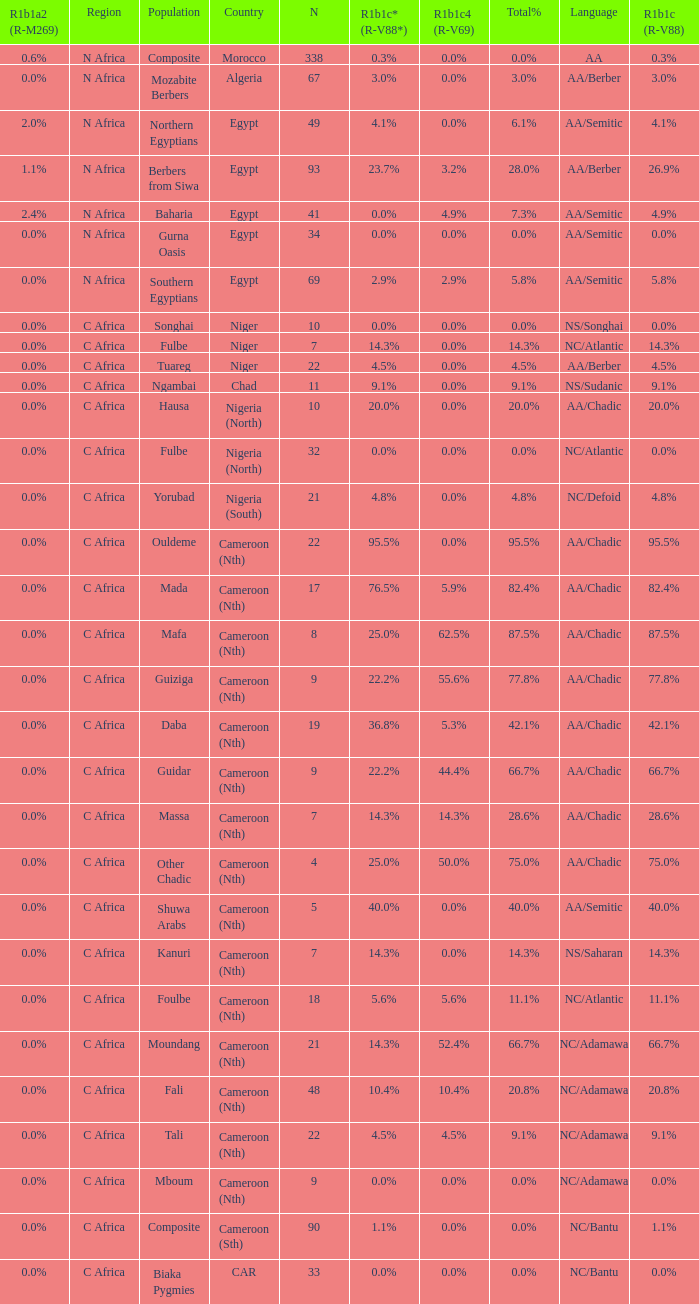What is the greatest n value for 5 9.0. 